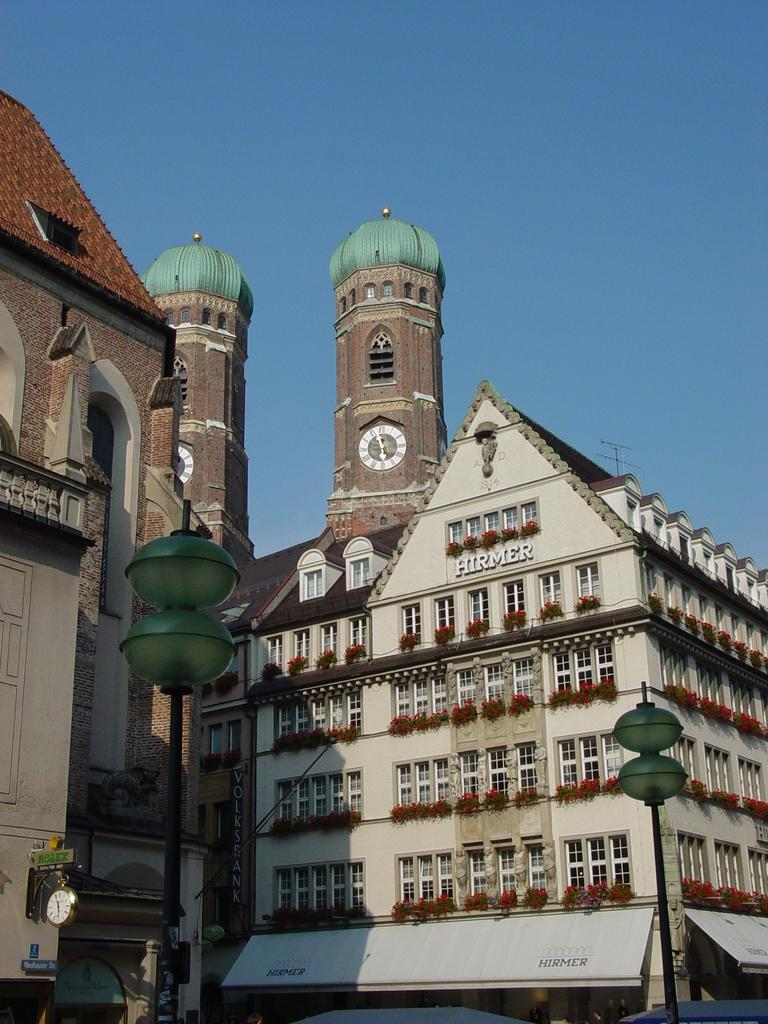What is the main subject in the center of the image? There are buildings in the center of the image. What can be seen at the bottom of the image? There are poles at the bottom of the image. What is visible in the background of the image? The sky is visible in the background of the image. How many pairs of shoes are visible in the image? There are no shoes present in the image. What type of insect can be seen crawling on the buildings in the image? There are no insects present in the image. 